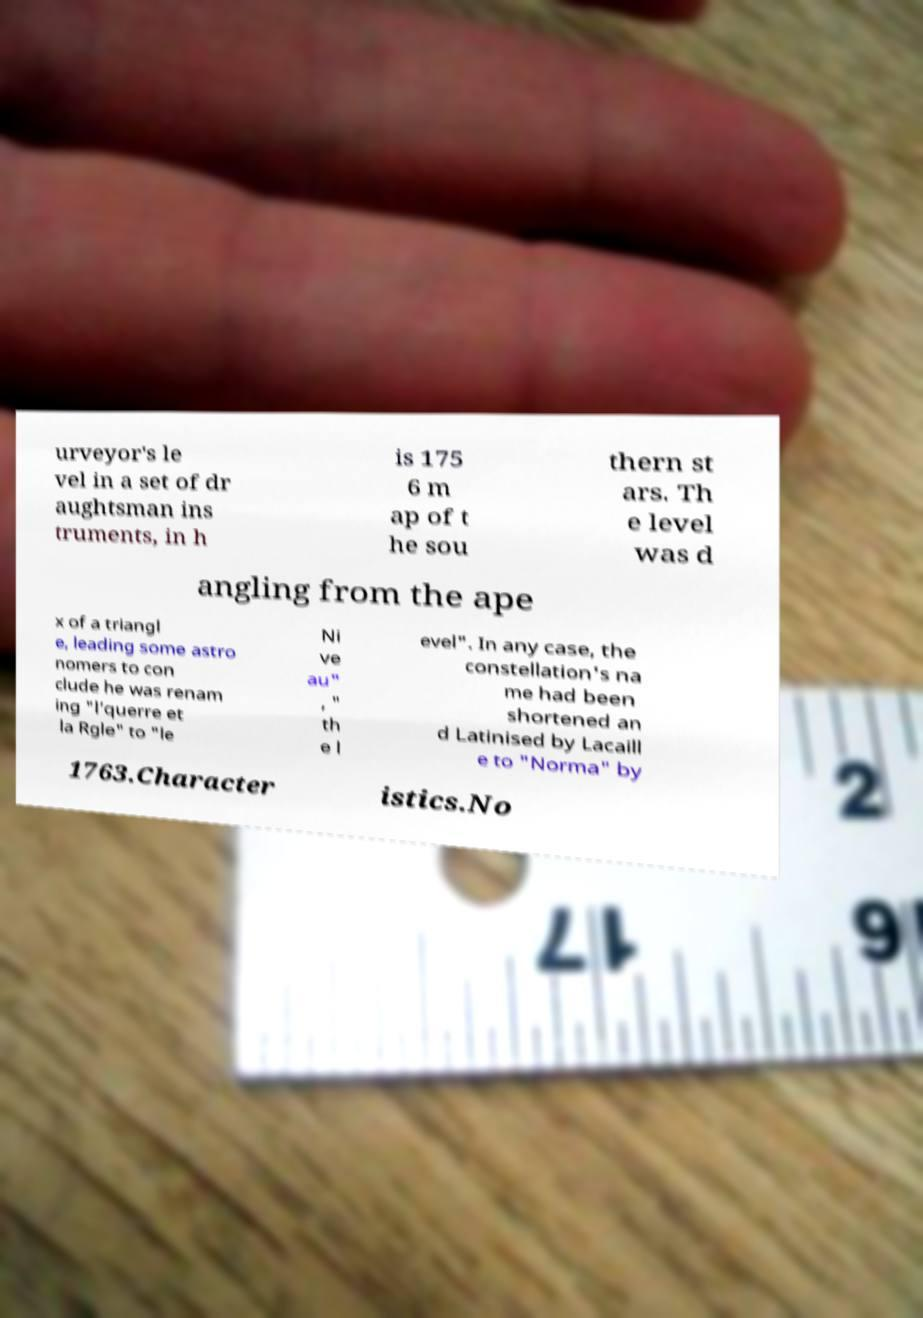There's text embedded in this image that I need extracted. Can you transcribe it verbatim? urveyor's le vel in a set of dr aughtsman ins truments, in h is 175 6 m ap of t he sou thern st ars. Th e level was d angling from the ape x of a triangl e, leading some astro nomers to con clude he was renam ing "l’querre et la Rgle" to "le Ni ve au" , " th e l evel". In any case, the constellation's na me had been shortened an d Latinised by Lacaill e to "Norma" by 1763.Character istics.No 